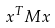Convert formula to latex. <formula><loc_0><loc_0><loc_500><loc_500>x ^ { T } M x</formula> 